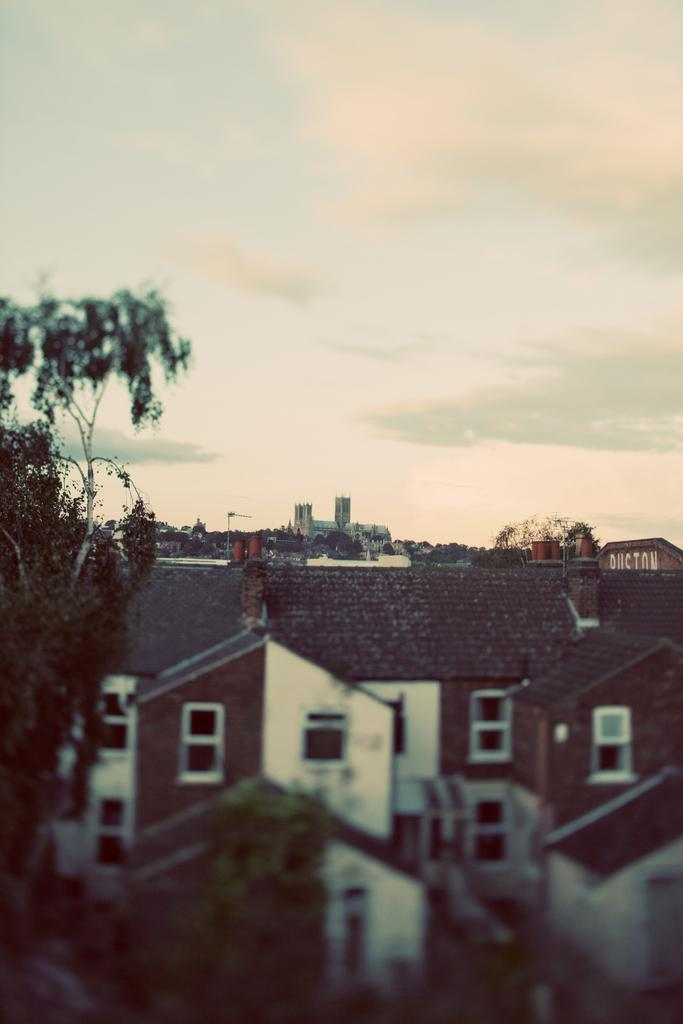What type of structures can be seen in the image? There is a group of buildings in the image. What other elements are present in the image besides the buildings? There are trees in the image. What part of the image is blurred? The bottom of the image is blurred. What is visible at the top of the image? The sky is visible at the top of the image. What is the chance of a cannon being fired in the image? There is no cannon present in the image, so it is not possible to determine the chance of it being fired. 